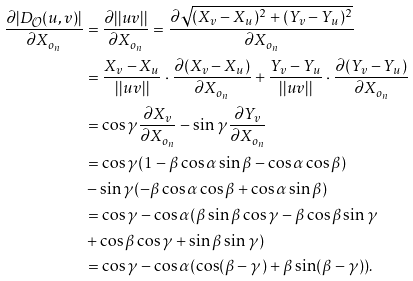<formula> <loc_0><loc_0><loc_500><loc_500>\frac { \partial { | D _ { \mathcal { O } } ( u , v ) | } } { \partial { X _ { o _ { n } } } } & = \frac { \partial { | | u v | | } } { \partial { X _ { o _ { n } } } } = \frac { \partial { \sqrt { ( X _ { v } - X _ { u } ) ^ { 2 } + ( Y _ { v } - Y _ { u } ) ^ { 2 } } } } { \partial { X _ { o _ { n } } } } \\ & = \frac { X _ { v } - X _ { u } } { | | u v | | } \cdot \frac { \partial { ( X _ { v } - X _ { u } ) } } { \partial { X _ { o _ { n } } } } + \frac { Y _ { v } - Y _ { u } } { | | u v | | } \cdot \frac { \partial { ( Y _ { v } - Y _ { u } ) } } { \partial { X _ { o _ { n } } } } \\ & = \cos { \gamma } \frac { \partial { X _ { v } } } { \partial { X _ { o _ { n } } } } - \sin { \gamma } \frac { \partial { Y _ { v } } } { \partial { X _ { o _ { n } } } } \\ & = \cos { \gamma } ( 1 - \beta \cos \alpha \sin \beta - \cos \alpha \cos \beta ) \\ & - \sin { \gamma } ( - \beta \cos \alpha \cos \beta + \cos \alpha \sin \beta ) \\ & = \cos { \gamma } - \cos \alpha ( \beta \sin \beta \cos \gamma - \beta \cos \beta \sin \gamma \\ & + \cos \beta \cos \gamma + \sin \beta \sin \gamma ) \\ & = \cos { \gamma } - \cos \alpha ( \cos ( \beta - \gamma ) + \beta \sin ( \beta - \gamma ) ) .</formula> 